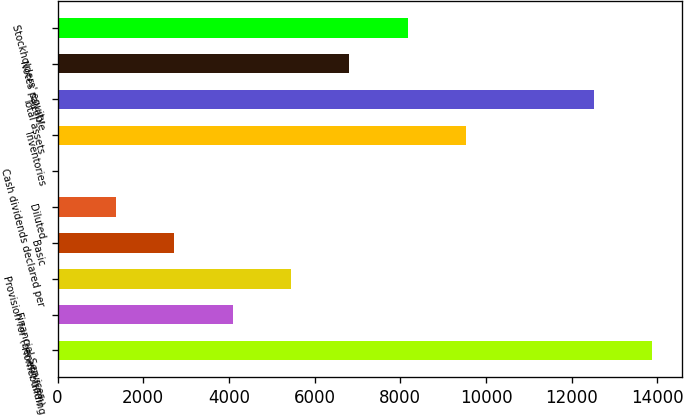Convert chart to OTSL. <chart><loc_0><loc_0><loc_500><loc_500><bar_chart><fcel>Homebuilding<fcel>Financial Services<fcel>Provision for (benefit from)<fcel>Basic<fcel>Diluted<fcel>Cash dividends declared per<fcel>Inventories<fcel>Total assets<fcel>Notes payable<fcel>Stockholders' equity<nl><fcel>13877.6<fcel>4088.8<fcel>5451.63<fcel>2725.97<fcel>1363.14<fcel>0.31<fcel>9540.12<fcel>12514.8<fcel>6814.46<fcel>8177.29<nl></chart> 